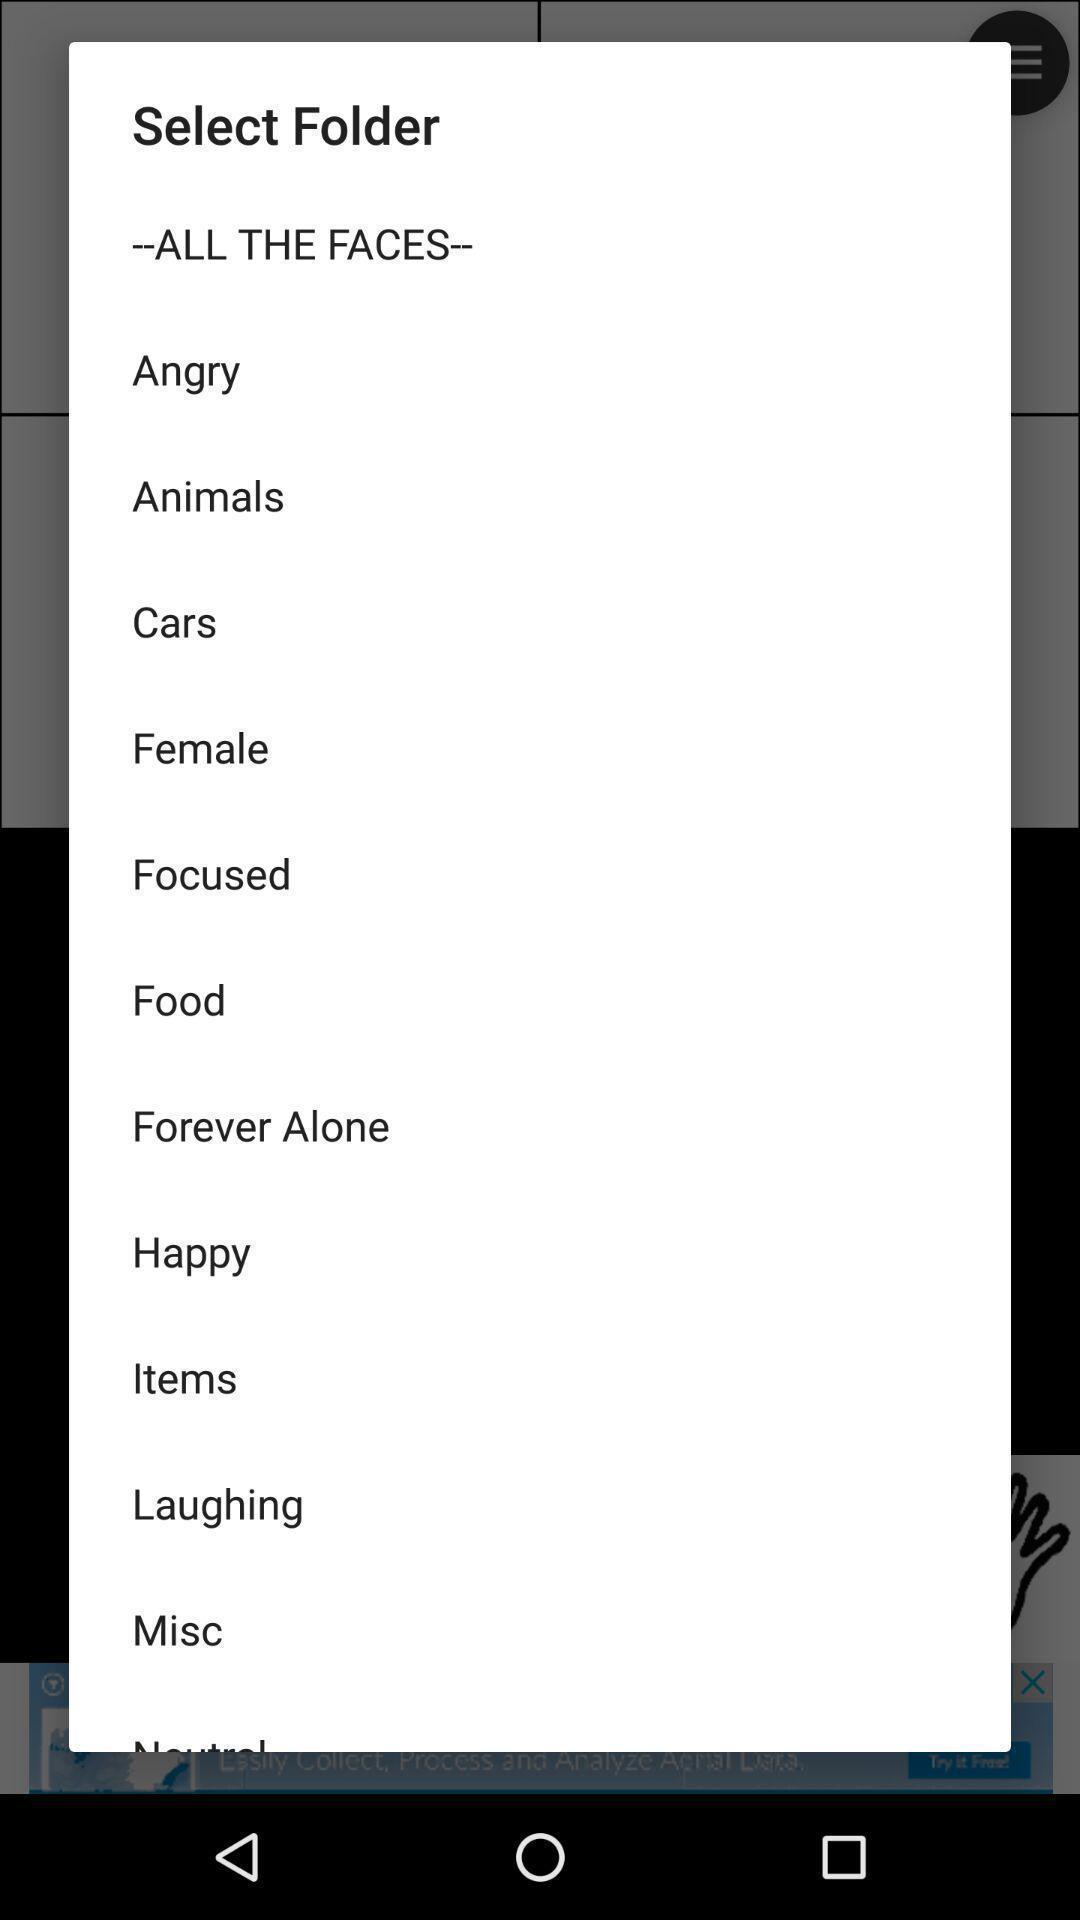Describe the content in this image. Pop-up showing list of various folders. 